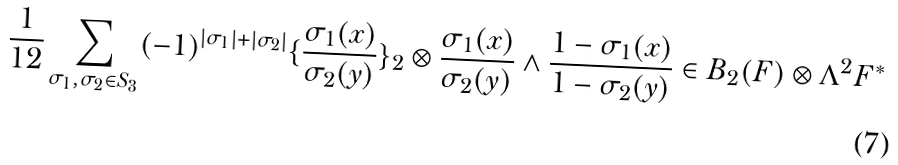<formula> <loc_0><loc_0><loc_500><loc_500>\frac { 1 } { 1 2 } \sum _ { \sigma _ { 1 } , \sigma _ { 2 } \in S _ { 3 } } ( - 1 ) ^ { | \sigma _ { 1 } | + | \sigma _ { 2 } | } \{ \frac { \sigma _ { 1 } ( x ) } { \sigma _ { 2 } ( y ) } \} _ { 2 } \otimes \frac { \sigma _ { 1 } ( x ) } { \sigma _ { 2 } ( y ) } \wedge \frac { 1 - \sigma _ { 1 } ( x ) } { 1 - \sigma _ { 2 } ( y ) } \in B _ { 2 } ( F ) \otimes \Lambda ^ { 2 } F ^ { \ast }</formula> 